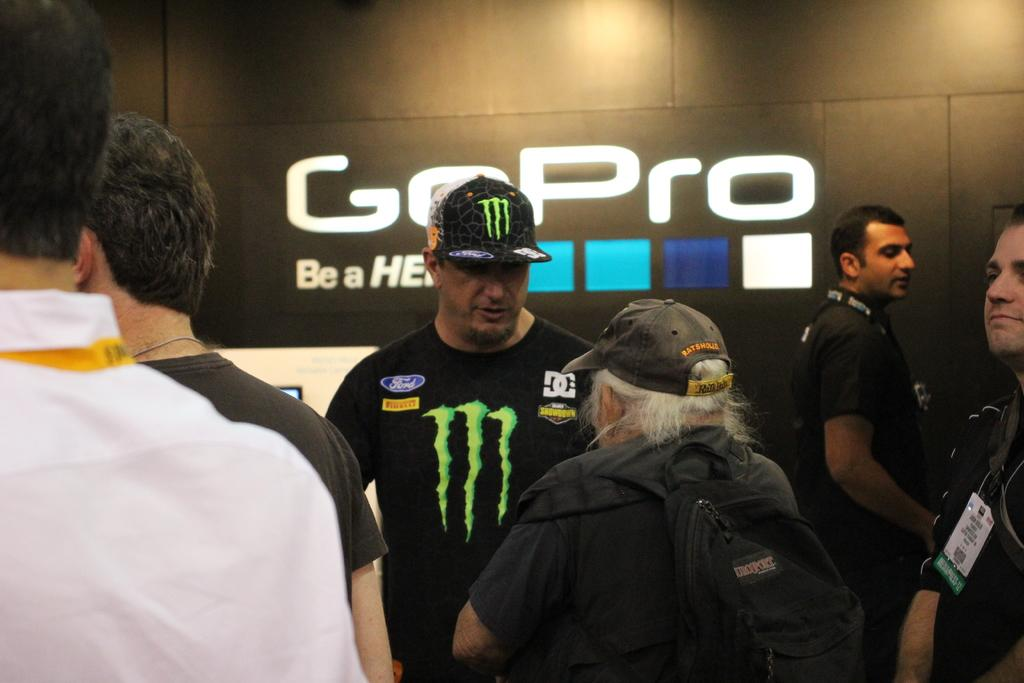<image>
Give a short and clear explanation of the subsequent image. A man in a Monster shirt and hat stands in front of the GoPro logo. 